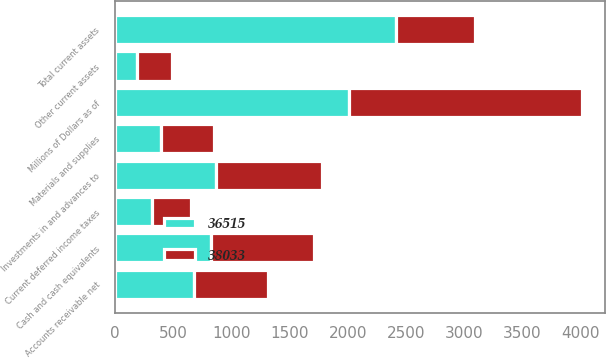Convert chart to OTSL. <chart><loc_0><loc_0><loc_500><loc_500><stacked_bar_chart><ecel><fcel>Millions of Dollars as of<fcel>Cash and cash equivalents<fcel>Accounts receivable net<fcel>Materials and supplies<fcel>Current deferred income taxes<fcel>Other current assets<fcel>Total current assets<fcel>Investments in and advances to<nl><fcel>38033<fcel>2007<fcel>878<fcel>632<fcel>453<fcel>336<fcel>295<fcel>679<fcel>912<nl><fcel>36515<fcel>2006<fcel>827<fcel>679<fcel>395<fcel>319<fcel>191<fcel>2411<fcel>865<nl></chart> 